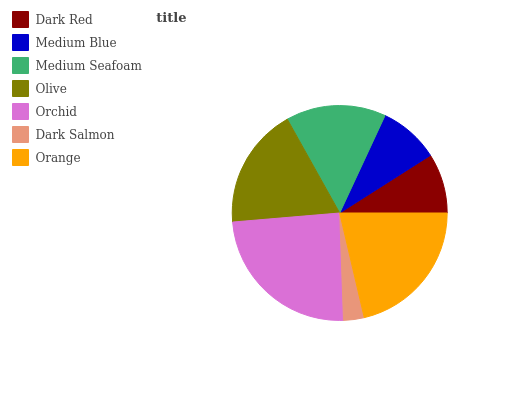Is Dark Salmon the minimum?
Answer yes or no. Yes. Is Orchid the maximum?
Answer yes or no. Yes. Is Medium Blue the minimum?
Answer yes or no. No. Is Medium Blue the maximum?
Answer yes or no. No. Is Medium Blue greater than Dark Red?
Answer yes or no. Yes. Is Dark Red less than Medium Blue?
Answer yes or no. Yes. Is Dark Red greater than Medium Blue?
Answer yes or no. No. Is Medium Blue less than Dark Red?
Answer yes or no. No. Is Medium Seafoam the high median?
Answer yes or no. Yes. Is Medium Seafoam the low median?
Answer yes or no. Yes. Is Dark Salmon the high median?
Answer yes or no. No. Is Olive the low median?
Answer yes or no. No. 